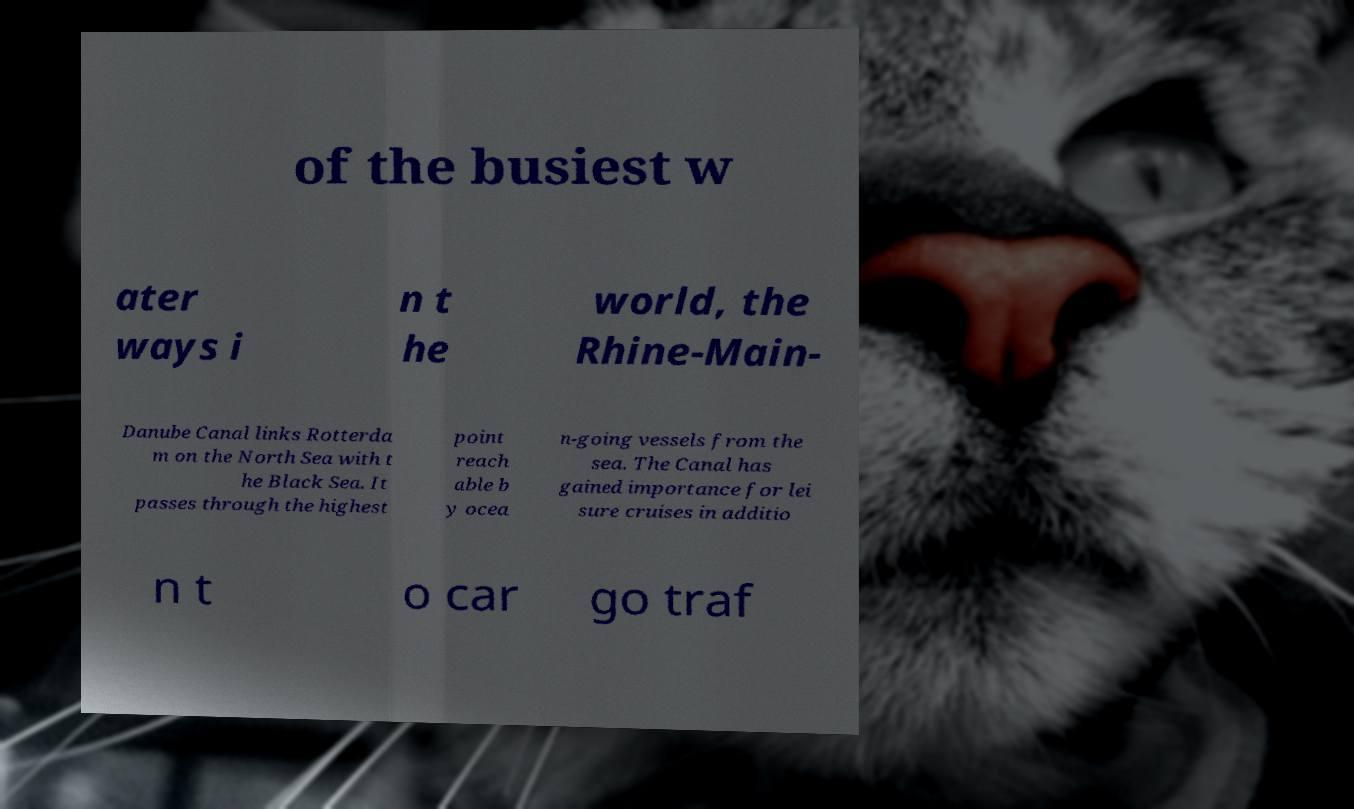Can you read and provide the text displayed in the image?This photo seems to have some interesting text. Can you extract and type it out for me? of the busiest w ater ways i n t he world, the Rhine-Main- Danube Canal links Rotterda m on the North Sea with t he Black Sea. It passes through the highest point reach able b y ocea n-going vessels from the sea. The Canal has gained importance for lei sure cruises in additio n t o car go traf 